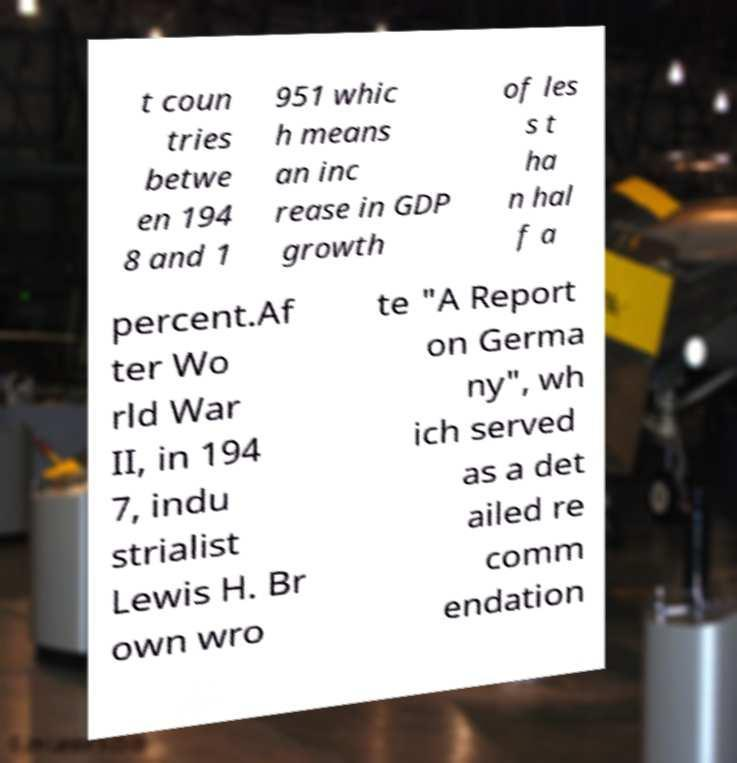Can you read and provide the text displayed in the image?This photo seems to have some interesting text. Can you extract and type it out for me? t coun tries betwe en 194 8 and 1 951 whic h means an inc rease in GDP growth of les s t ha n hal f a percent.Af ter Wo rld War II, in 194 7, indu strialist Lewis H. Br own wro te "A Report on Germa ny", wh ich served as a det ailed re comm endation 